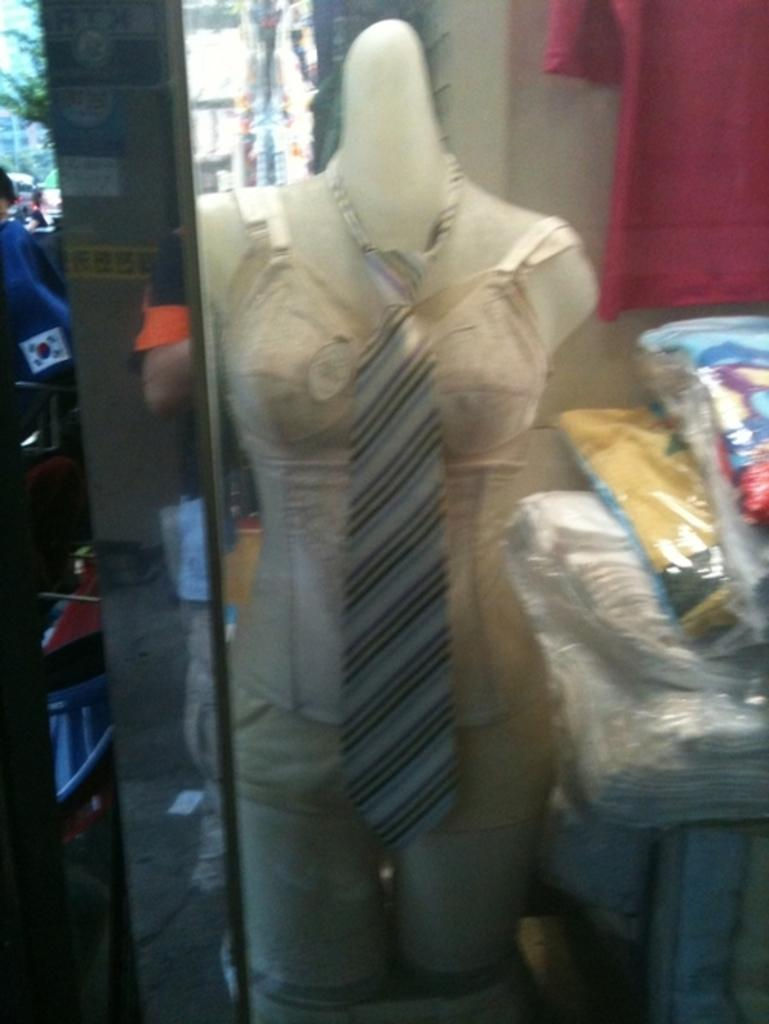What is the main subject in the image? There is a mannequin in the image. What is the mannequin wearing? The mannequin is wearing clothes, including a tie around its neck. Are there any other clothes visible in the image? Yes, there are additional clothes visible in the image. What color is the t-shirt hanging on the wall in the image? The t-shirt hanging on the wall is red. How many rings does the mannequin have on its fingers in the image? There are no rings visible on the mannequin's fingers in the image. 